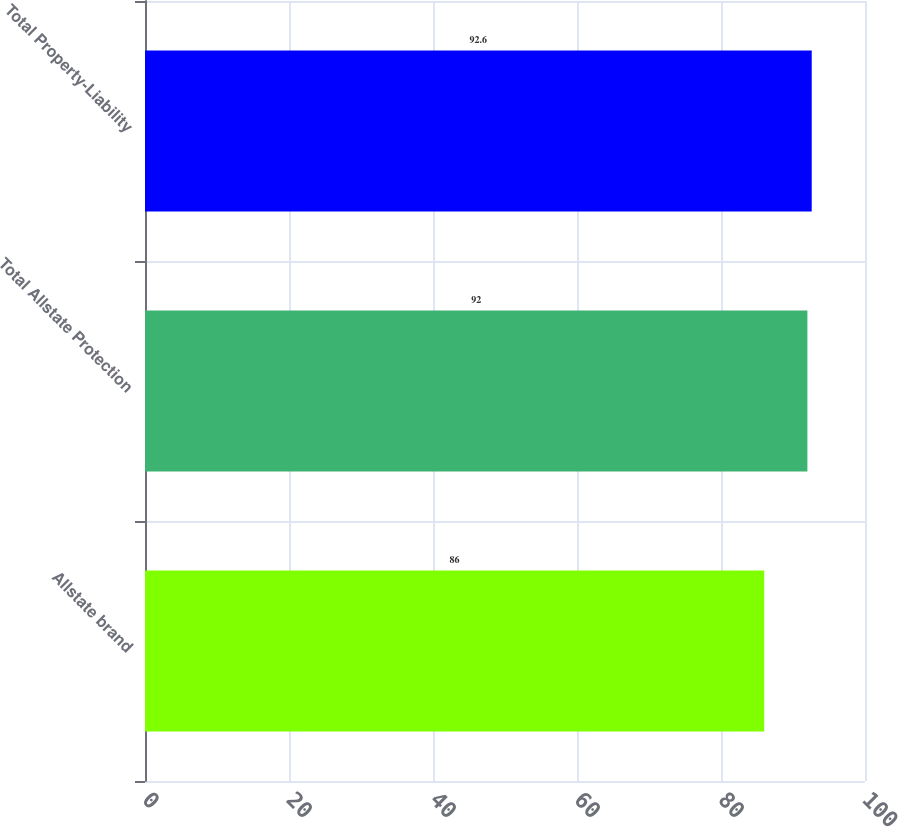Convert chart to OTSL. <chart><loc_0><loc_0><loc_500><loc_500><bar_chart><fcel>Allstate brand<fcel>Total Allstate Protection<fcel>Total Property-Liability<nl><fcel>86<fcel>92<fcel>92.6<nl></chart> 